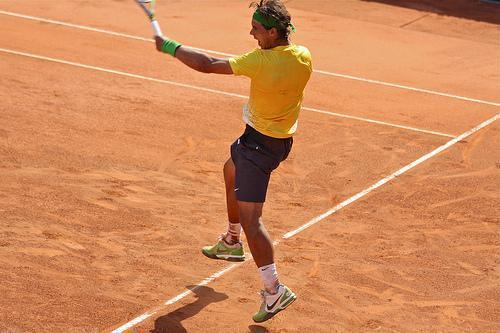How many players are visible?
Give a very brief answer. 1. 